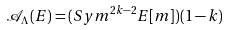<formula> <loc_0><loc_0><loc_500><loc_500>\mathcal { A } _ { \Lambda } ( E ) = ( S y m ^ { 2 k - 2 } E [ m ] ) ( 1 - k )</formula> 